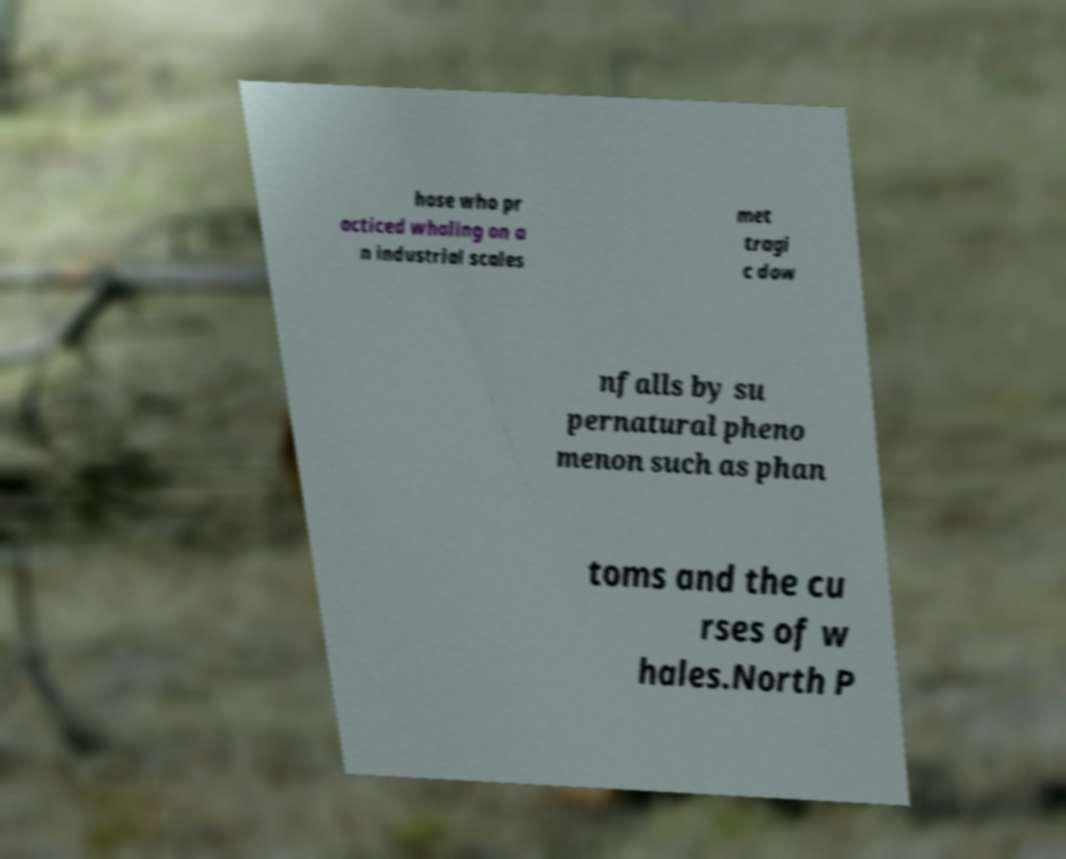There's text embedded in this image that I need extracted. Can you transcribe it verbatim? hose who pr acticed whaling on a n industrial scales met tragi c dow nfalls by su pernatural pheno menon such as phan toms and the cu rses of w hales.North P 